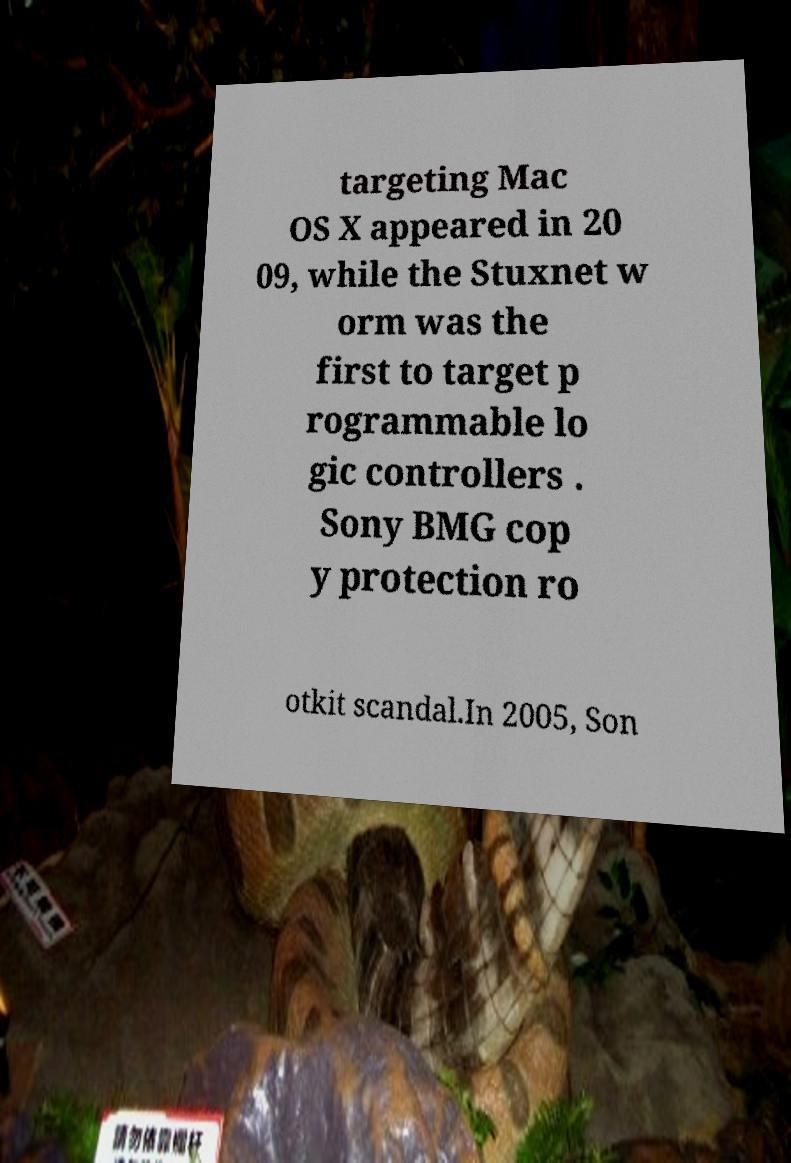Could you extract and type out the text from this image? targeting Mac OS X appeared in 20 09, while the Stuxnet w orm was the first to target p rogrammable lo gic controllers . Sony BMG cop y protection ro otkit scandal.In 2005, Son 